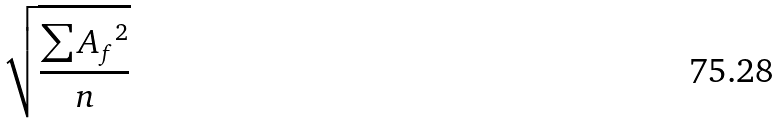Convert formula to latex. <formula><loc_0><loc_0><loc_500><loc_500>\sqrt { \frac { \sum { A _ { f } } ^ { 2 } } { n } }</formula> 